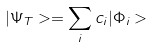<formula> <loc_0><loc_0><loc_500><loc_500>| \Psi _ { T } > = \sum _ { i } c _ { i } | \Phi _ { i } ></formula> 